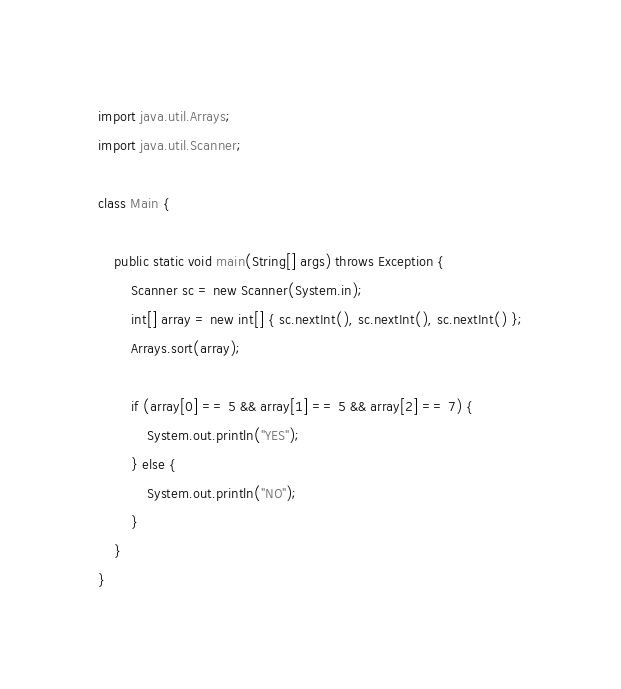<code> <loc_0><loc_0><loc_500><loc_500><_Java_>import java.util.Arrays;
import java.util.Scanner;

class Main {

	public static void main(String[] args) throws Exception {
		Scanner sc = new Scanner(System.in);
		int[] array = new int[] { sc.nextInt(), sc.nextInt(), sc.nextInt() };
		Arrays.sort(array);

		if (array[0] == 5 && array[1] == 5 && array[2] == 7) {
			System.out.println("YES");
		} else {
			System.out.println("NO");
		}
	}
}
</code> 